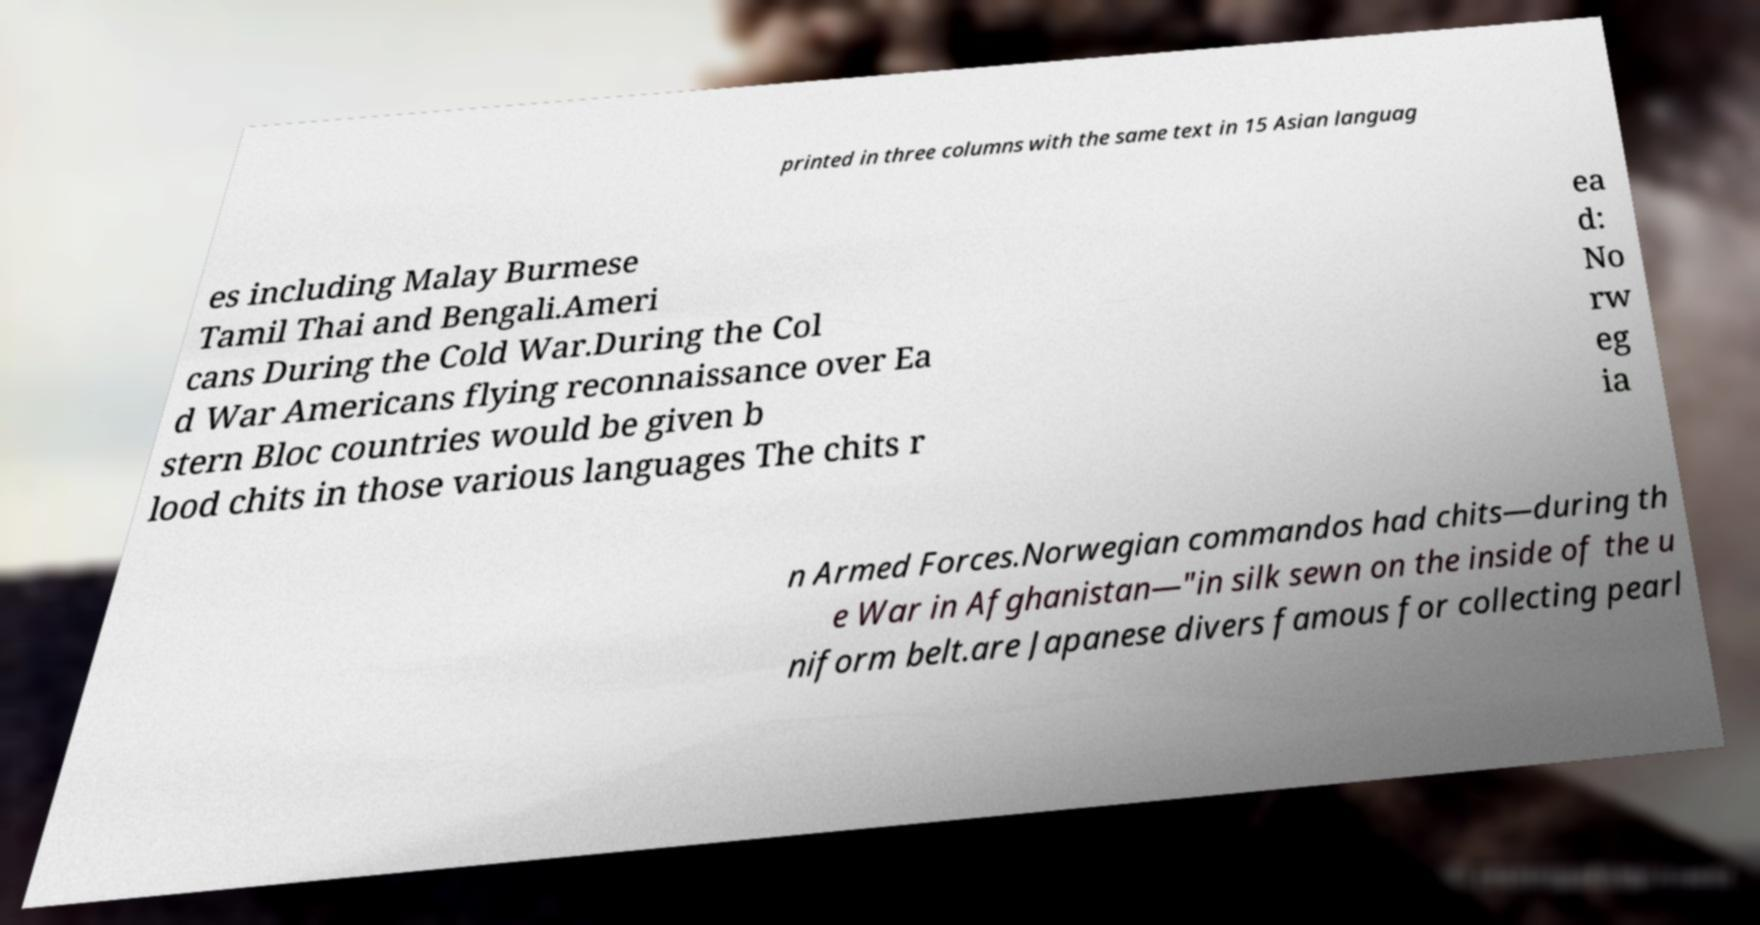Could you assist in decoding the text presented in this image and type it out clearly? printed in three columns with the same text in 15 Asian languag es including Malay Burmese Tamil Thai and Bengali.Ameri cans During the Cold War.During the Col d War Americans flying reconnaissance over Ea stern Bloc countries would be given b lood chits in those various languages The chits r ea d: No rw eg ia n Armed Forces.Norwegian commandos had chits—during th e War in Afghanistan—"in silk sewn on the inside of the u niform belt.are Japanese divers famous for collecting pearl 